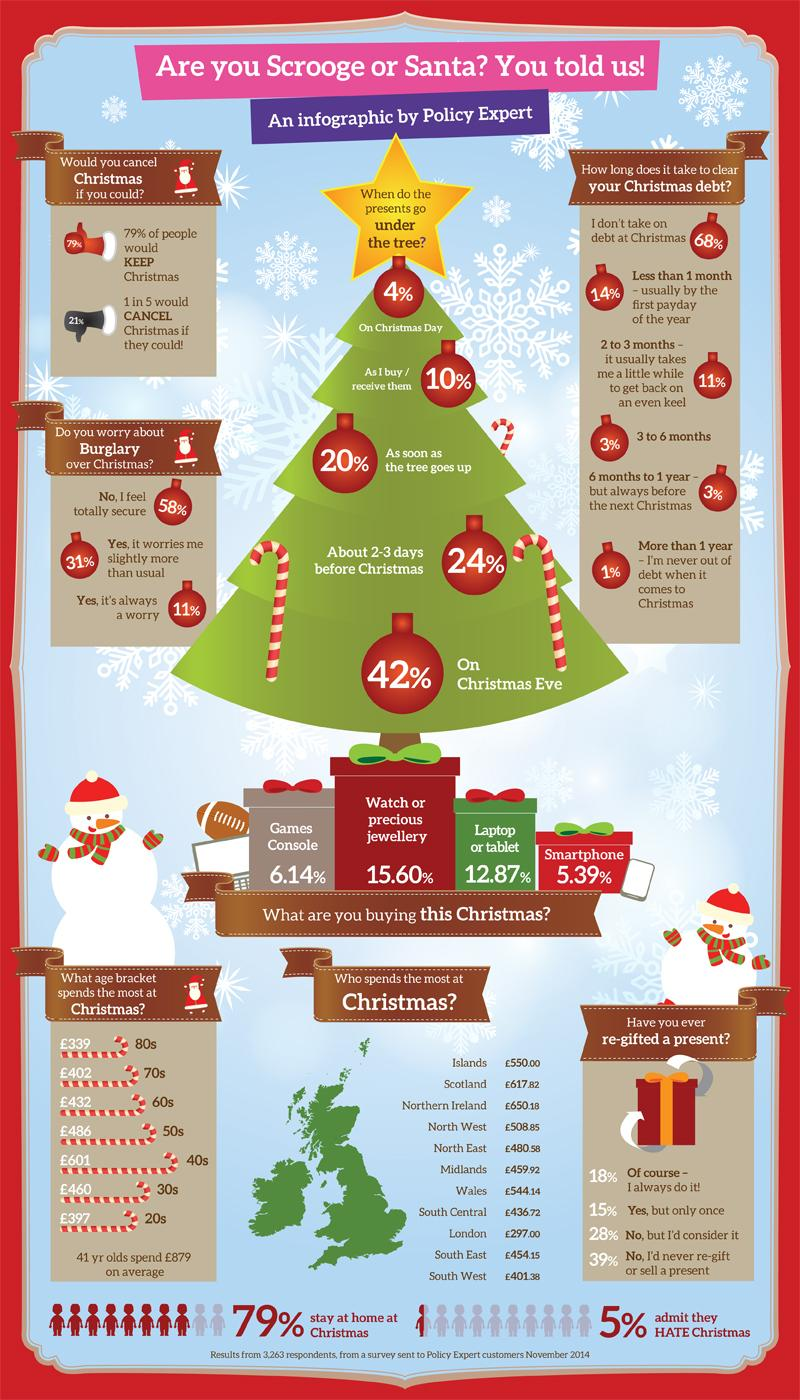Identify some key points in this picture. According to the given statistic, 42% of people worry either slightly or always about burglary during the Christmas holiday season. South Central spends the third least amount at Christmas out of all the areas. According to the question, the second-highest age bracket for spending during the Christmas season is those in their 50s. According to the given information, approximately 4% of people take more than 6 months to clear their Christmas debt. According to a study, 33% of people have re-gifted a present at least once. 